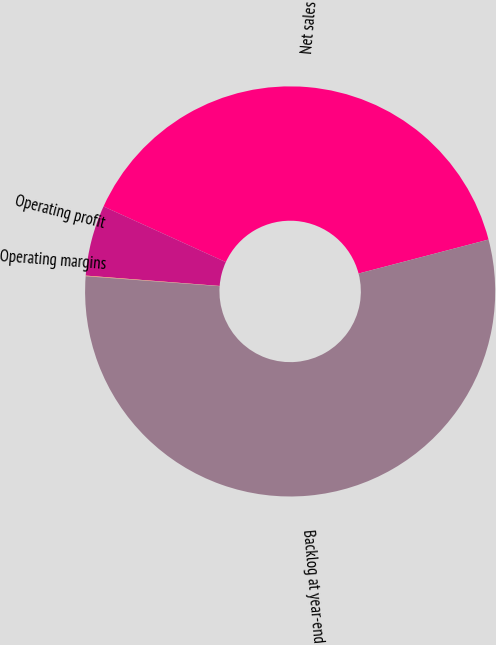Convert chart to OTSL. <chart><loc_0><loc_0><loc_500><loc_500><pie_chart><fcel>Net sales<fcel>Operating profit<fcel>Operating margins<fcel>Backlog at year-end<nl><fcel>39.13%<fcel>5.57%<fcel>0.05%<fcel>55.25%<nl></chart> 